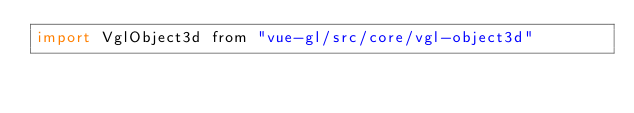<code> <loc_0><loc_0><loc_500><loc_500><_JavaScript_>import VglObject3d from "vue-gl/src/core/vgl-object3d"</code> 